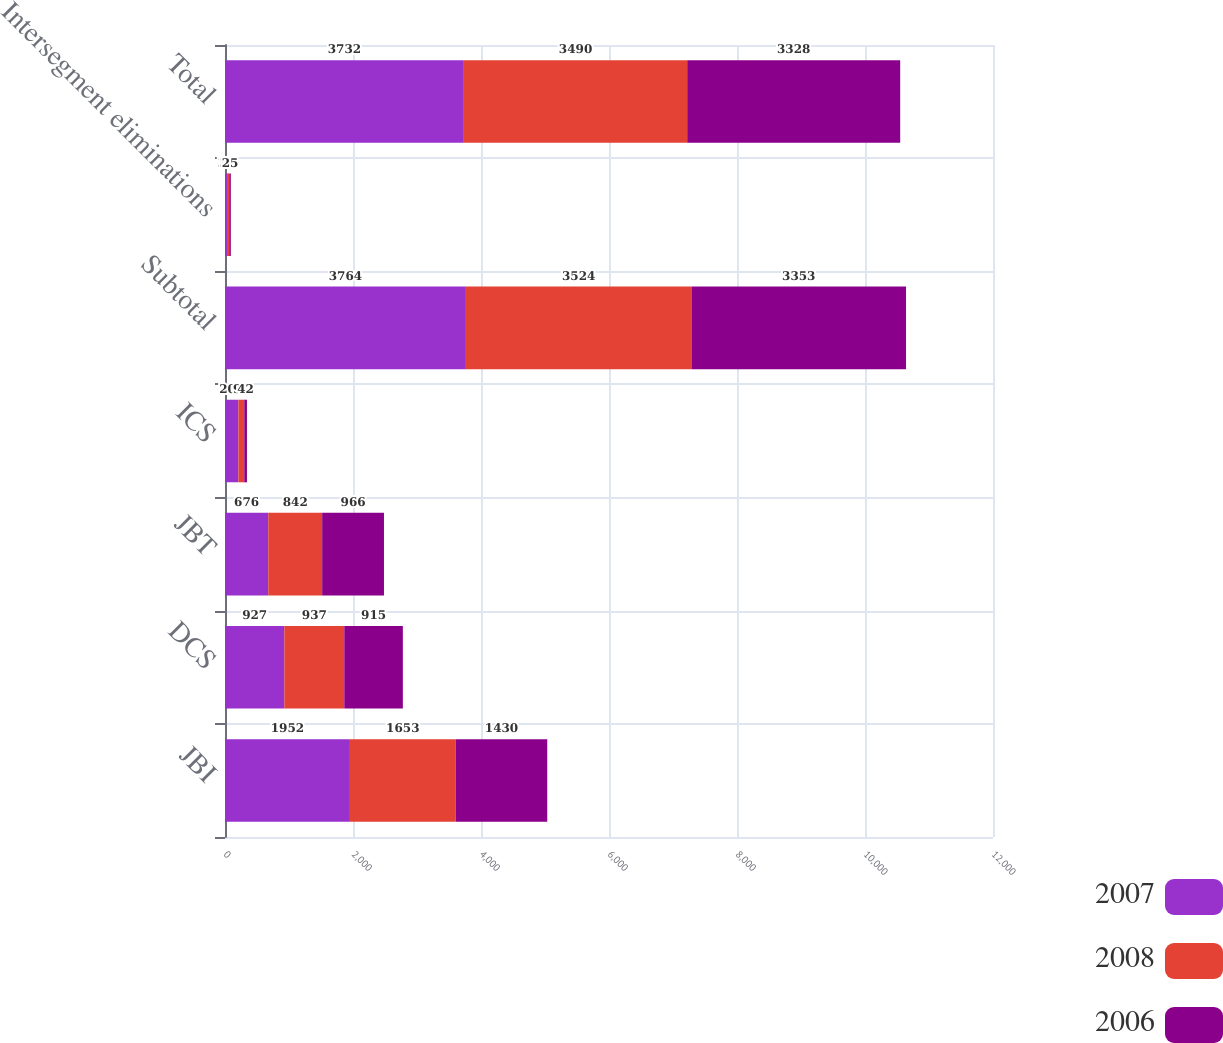<chart> <loc_0><loc_0><loc_500><loc_500><stacked_bar_chart><ecel><fcel>JBI<fcel>DCS<fcel>JBT<fcel>ICS<fcel>Subtotal<fcel>Intersegment eliminations<fcel>Total<nl><fcel>2007<fcel>1952<fcel>927<fcel>676<fcel>209<fcel>3764<fcel>32<fcel>3732<nl><fcel>2008<fcel>1653<fcel>937<fcel>842<fcel>92<fcel>3524<fcel>34<fcel>3490<nl><fcel>2006<fcel>1430<fcel>915<fcel>966<fcel>42<fcel>3353<fcel>25<fcel>3328<nl></chart> 